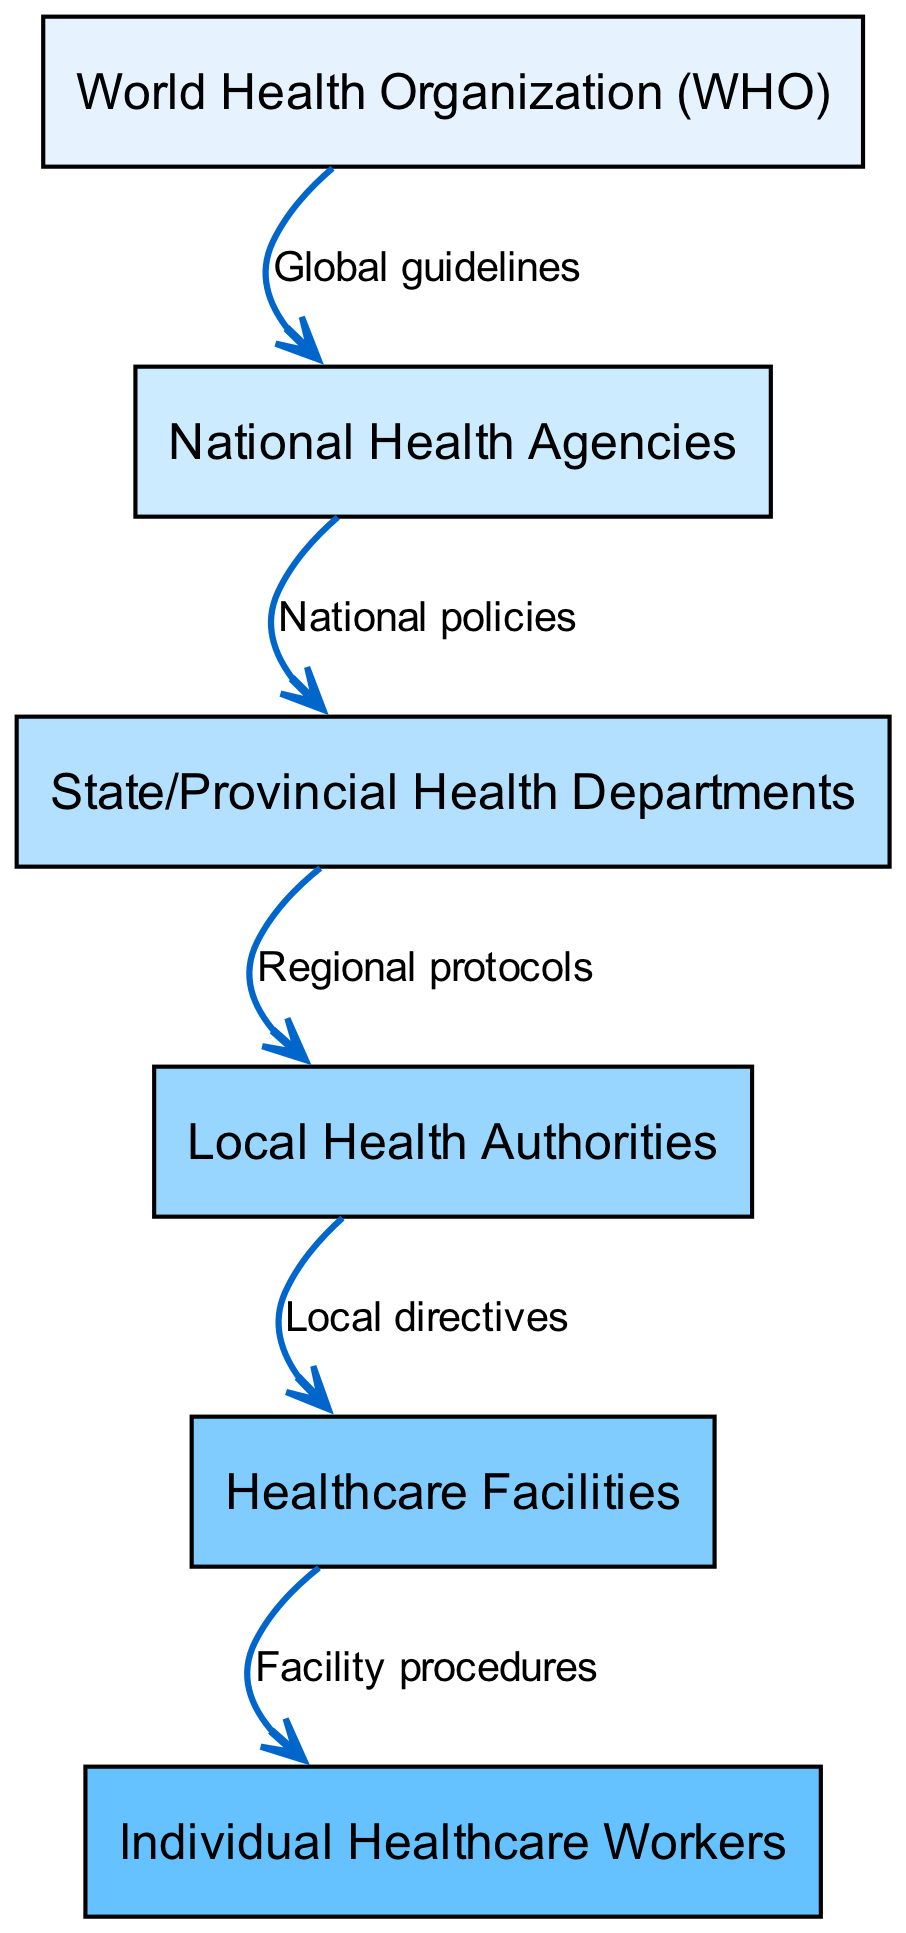What is the top level in the food chain? The top level in the food chain is represented by the "World Health Organization (WHO)", which is the highest node in the diagram.
Answer: World Health Organization (WHO) How many nodes are in the diagram? Counting all the distinct elements in the diagram shows there are six nodes represented at various levels.
Answer: 6 What labels connect National Health Agencies to State/Provincial Health Departments? The connection between "National Health Agencies" and "State/Provincial Health Departments" is labeled as "National policies".
Answer: National policies Which level corresponds to Healthcare Facilities? The "Healthcare Facilities" are represented at level 5 in the diagram, indicating their position in the regulatory framework hierarchy.
Answer: 5 What is the connection label from Local Health Authorities to Healthcare Facilities? The edge connecting "Local Health Authorities" to "Healthcare Facilities" is labeled as "Local directives". This indicates the nature of the relationship.
Answer: Local directives How does the hierarchy progress from WHO to local authorities? The hierarchy flows from WHO (global guidelines) to National Health Agencies (national policies), then to State/Provincial Health Departments (regional protocols), continuing to Local Health Authorities (local directives), and finally to Healthcare Facilities (facility procedures). Each level supports the next in disease prevention regulations.
Answer: WHO to National Health Agencies to State/Provincial Health Departments to Local Health Authorities to Healthcare Facilities What does the connection between State/Provincial Health Departments and Local Health Authorities represent? This connection is labeled as "Regional protocols", which signifies standardized instructions that guide local health practices based on regional needs.
Answer: Regional protocols Which node directly receives directives from Local Health Authorities? The node that receives directives directly from "Local Health Authorities" is "Healthcare Facilities", indicating local operational implementations.
Answer: Healthcare Facilities 